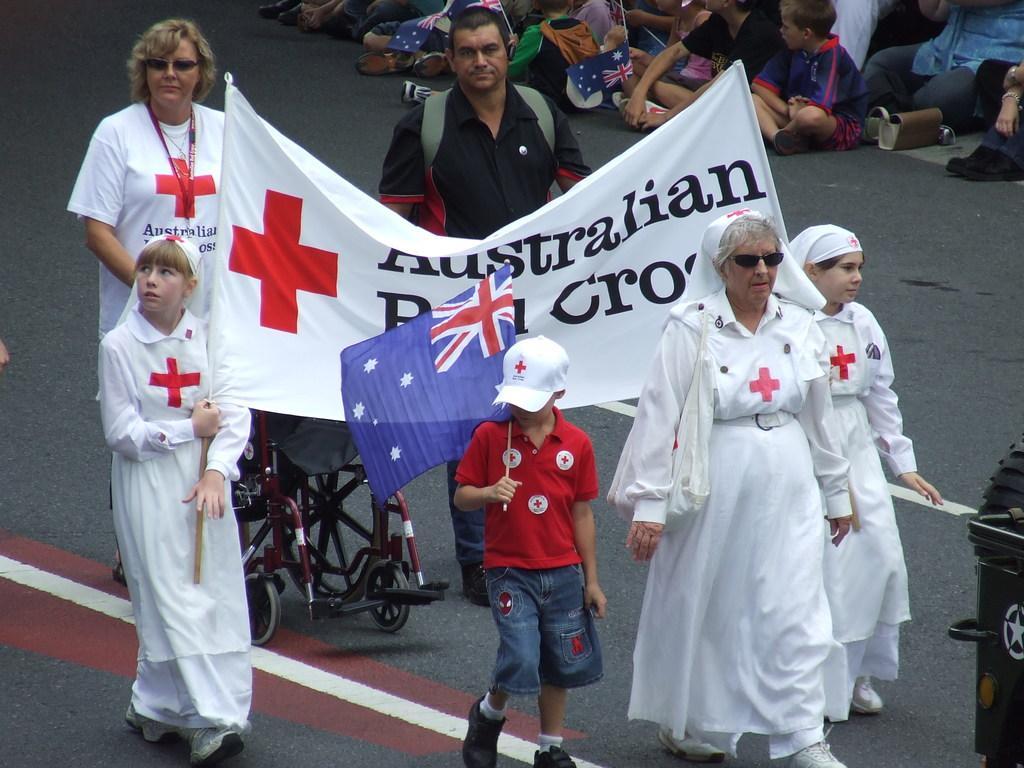Can you describe this image briefly? In this image I can see in the middle a boy is walking by holding the flag. Beside him few women are walking by holding the banner, on the left side a woman is pushing the wheel chair. At the top there is a man, he is wearing a black color t-shirt. Few people are sitting on the road. 